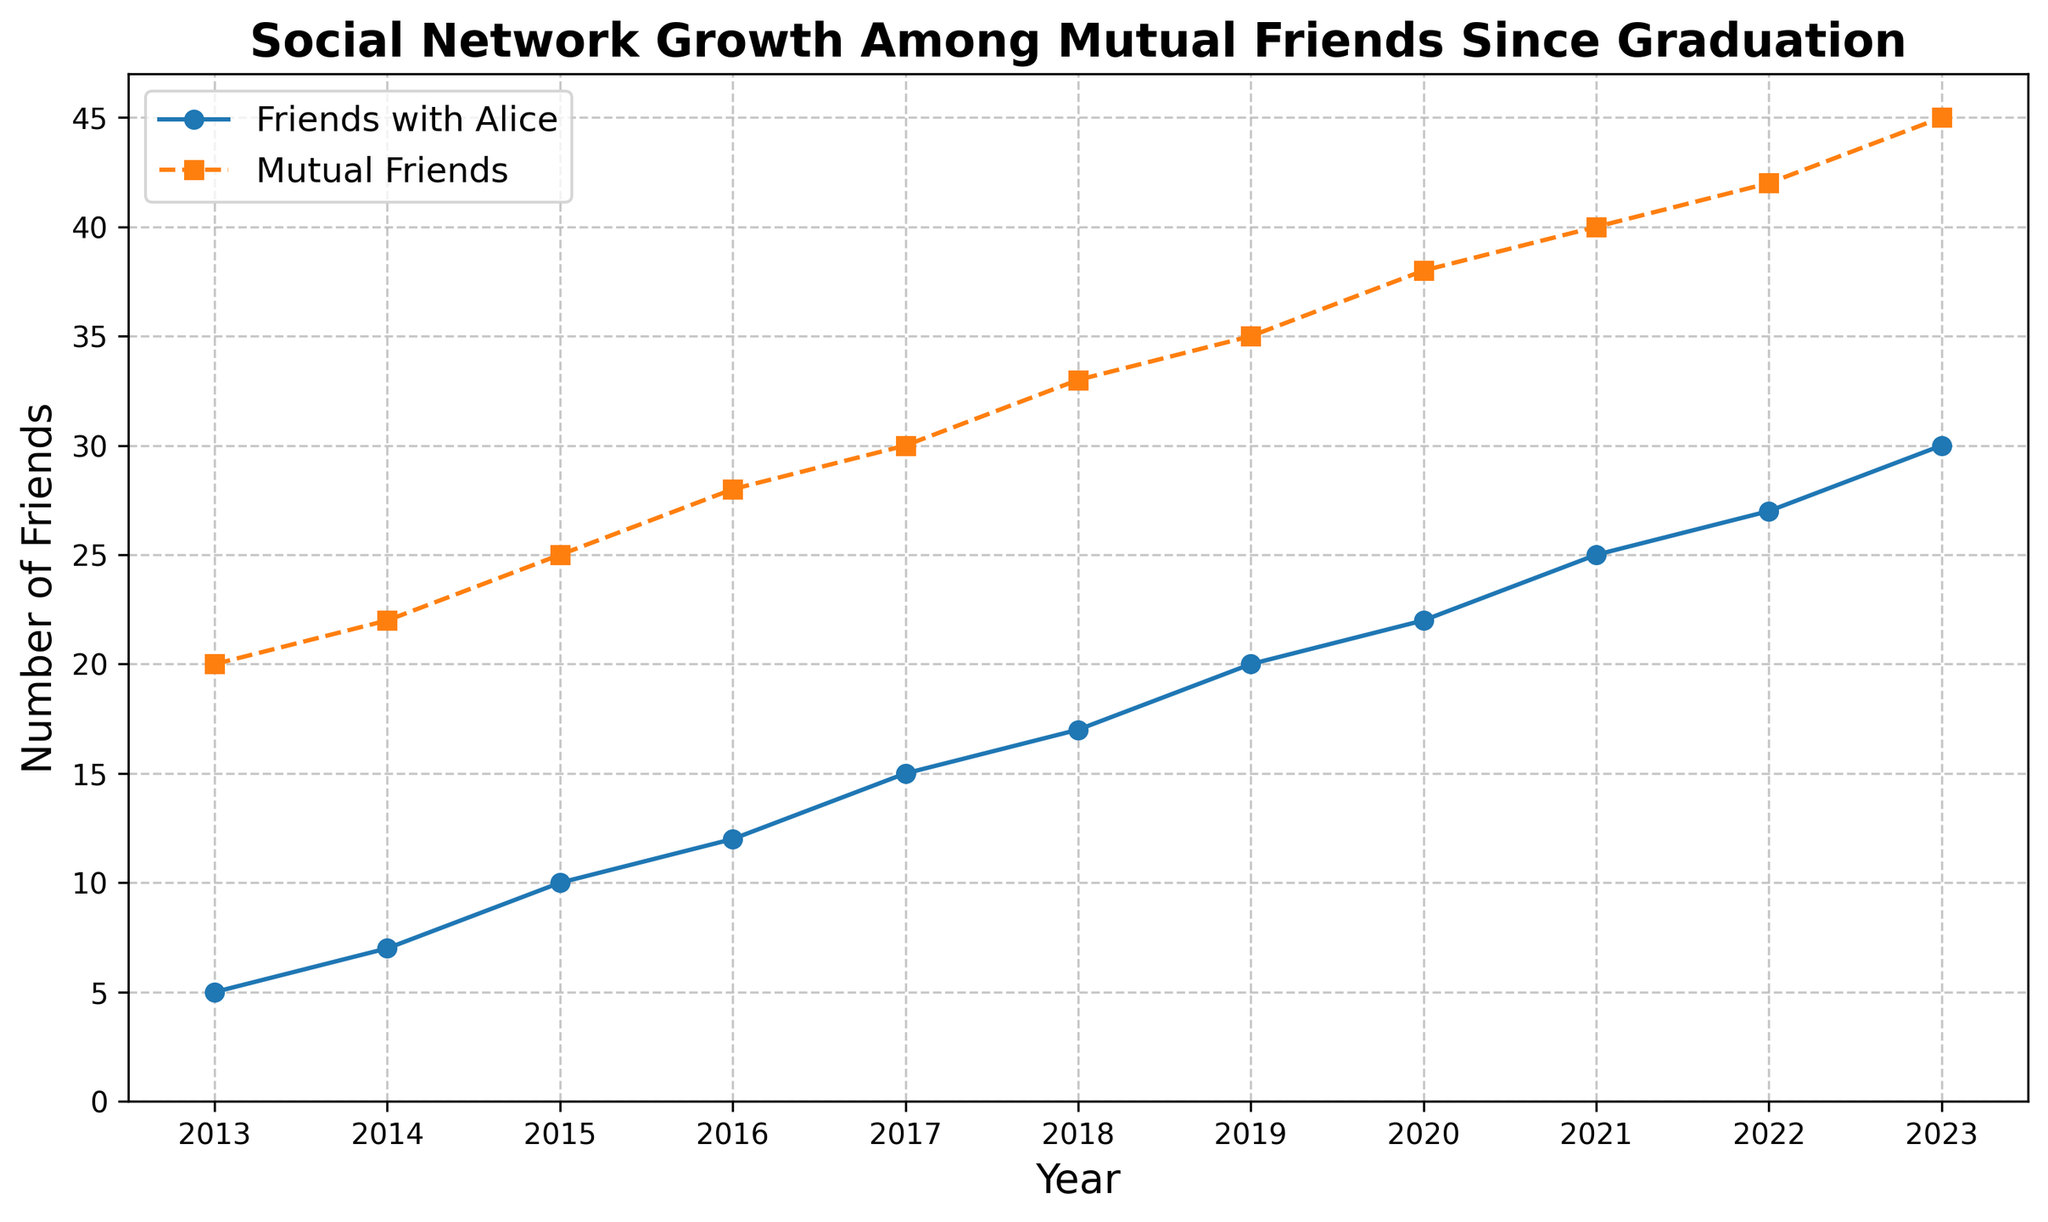What's the number of mutual friends in 2020? Look at the "Mutual Friends" line where it intersects the year 2020 on the x-axis. The y-value here is 38.
Answer: 38 By how many did the number of friends with Alice increase from 2013 to 2014? In 2013, the number of friends with Alice was 5, and in 2014 it was 7. The difference is calculated as 7 - 5 = 2.
Answer: 2 Which year saw the highest number of mutual friends, and what was that number? The graph shows that the highest point on the "Mutual Friends" line is in 2023, where the number reaches 45.
Answer: 2023, 45 What is the shape of the trend for both lines between 2013 and 2023? Both lines show a consistently upward trend from 2013 to 2023, indicating continuous growth in both friends with Alice and mutual friends.
Answer: Upward trend What is the difference between the number of mutual friends and friends with Alice in 2019? In 2019, the number of mutual friends is 35, and friends with Alice is 20. The difference is 35 - 20 = 15.
Answer: 15 Between which consecutive years did the number of friends with Alice increase the most? To find this, calculate the increments for each year and compare them. From 2014 to 2015, the increase is 10 - 7 = 3; from 2013 to 2014, it is 7 - 5 = 2. The largest increase is from 2021 to 2022, where it increased from 25 to 27, which is 2.
Answer: From 2021 to 2022 What is the average number of friends with Alice over the years shown? Add all the yearly values of friends with Alice and divide by the number of years. (5 + 7 + 10 + 12 + 15 + 17 + 20 + 22 + 25 + 27 + 30) / 11 = 17.
Answer: 17 Do mutual friends increase more than friends with Alice from 2016 to 2020? Calculate the increase for both sets from 2016 to 2020. The number of mutual friends increases from 28 to 38 (10), and friends with Alice increases from 12 to 22 (10). They increase by the same amount.
Answer: No, they increase by the same amount In what year did the number of friends with Alice surpass 20? Check the graph to find when the "Friends with Alice" line first exceeds 20. This occurs in 2019.
Answer: 2019 Is the rate of growth for mutual friends always higher than the rate for friends with Alice? To determine this, examine the slope of each line per year. The mutual friends line generally has a more consistent upward slope than the friends with Alice line. However, specific yearly growth rates need to be compared for exact differences. While mutual friends show a more consistent increase, there are individual years where friends with Alice increase more, such as from 2014 to 2015.
Answer: No, it varies year by year 